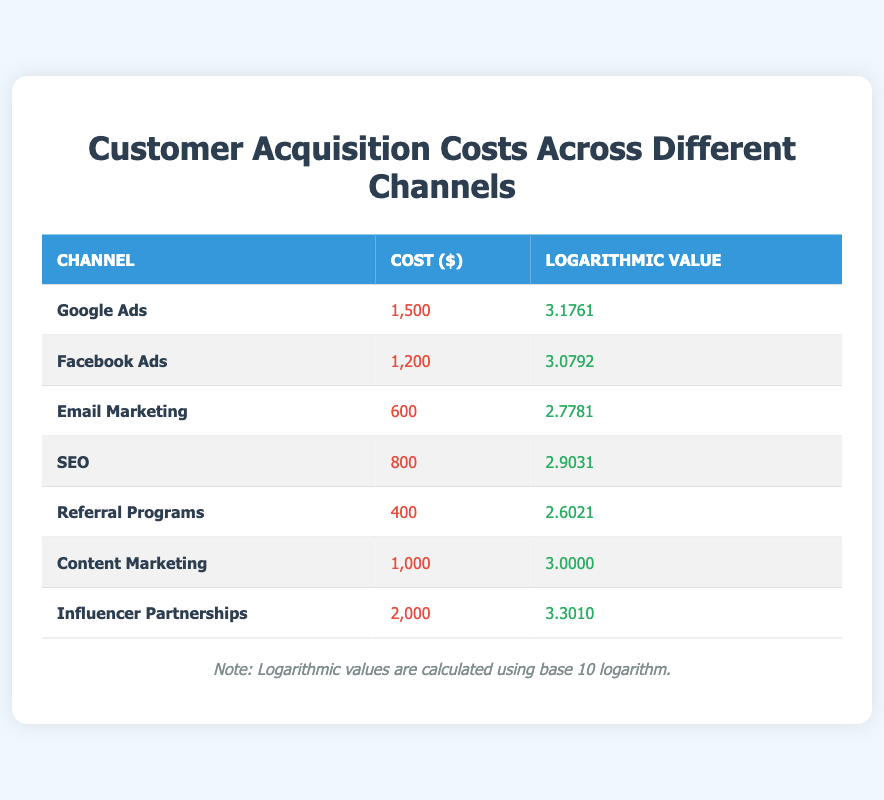What is the customer acquisition cost for Google Ads? The table lists Google Ads with a customer acquisition cost of 1500 dollars.
Answer: 1500 Which channel has the lowest customer acquisition cost? In the table, Referral Programs has the lowest cost listed at 400 dollars.
Answer: Referral Programs What is the logarithmic value for Facebook Ads? According to the table, the logarithmic value for Facebook Ads is 3.0792.
Answer: 3.0792 What is the difference in cost between Influencer Partnerships and Email Marketing? Influencer Partnerships cost 2000 dollars and Email Marketing costs 600 dollars. The difference is 2000 - 600 = 1400 dollars.
Answer: 1400 Is the logarithmic value for Content Marketing greater than 3? The table shows that the logarithmic value for Content Marketing is exactly 3.0000, so it is not greater than 3.
Answer: No What are the average and median customer acquisition costs across all channels? The total costs for all channels are 1500 + 1200 + 600 + 800 + 400 + 1000 + 2000 = 6500 dollars, with 7 channels total. The average is 6500/7 = 928.57 dollars. The costs in ascending order: 400, 600, 800, 1000, 1200, 1500, 2000 gives a median of 1000.
Answer: Average: 928.57, Median: 1000 How many channels have a logarithmic value greater than 3? The channels with a logarithmic value greater than 3 are Google Ads (3.1761), Influencer Partnerships (3.3010), and Content Marketing (3.0000). This totals to 3 channels.
Answer: 3 Which channel has the highest logarithmic value? The table indicates that Influencer Partnerships holds the highest logarithmic value at 3.3010.
Answer: Influencer Partnerships What is the sum of the logarithmic values for Email Marketing and SEO? The logarithmic values for Email Marketing and SEO are 2.7781 and 2.9031 respectively. Their sum is 2.7781 + 2.9031 = 5.6812.
Answer: 5.6812 